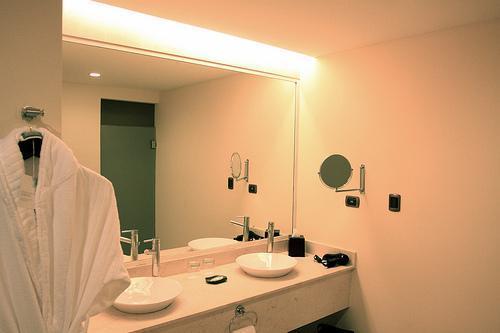How many sinks are there in this bathroom?
Give a very brief answer. 2. 